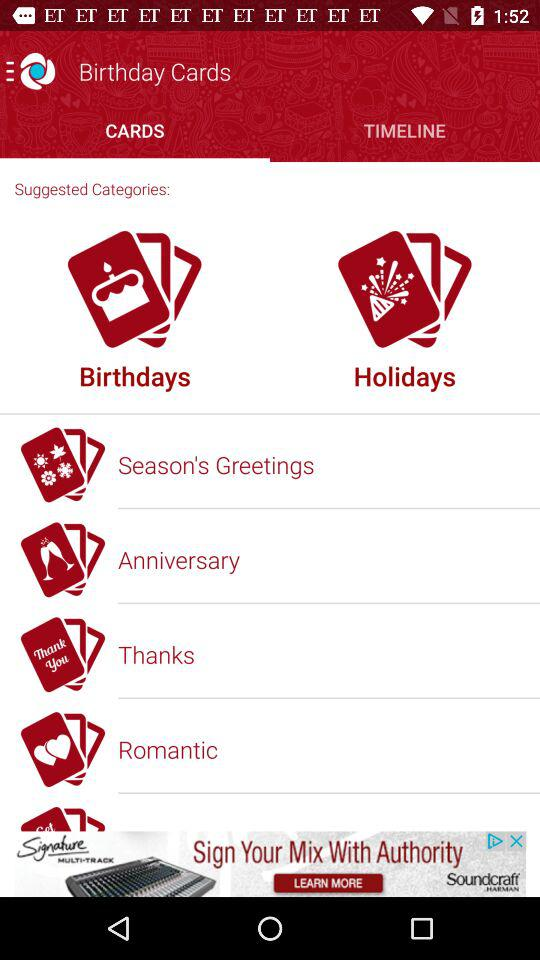Which tab is selected? The selected tab is "CARDS". 